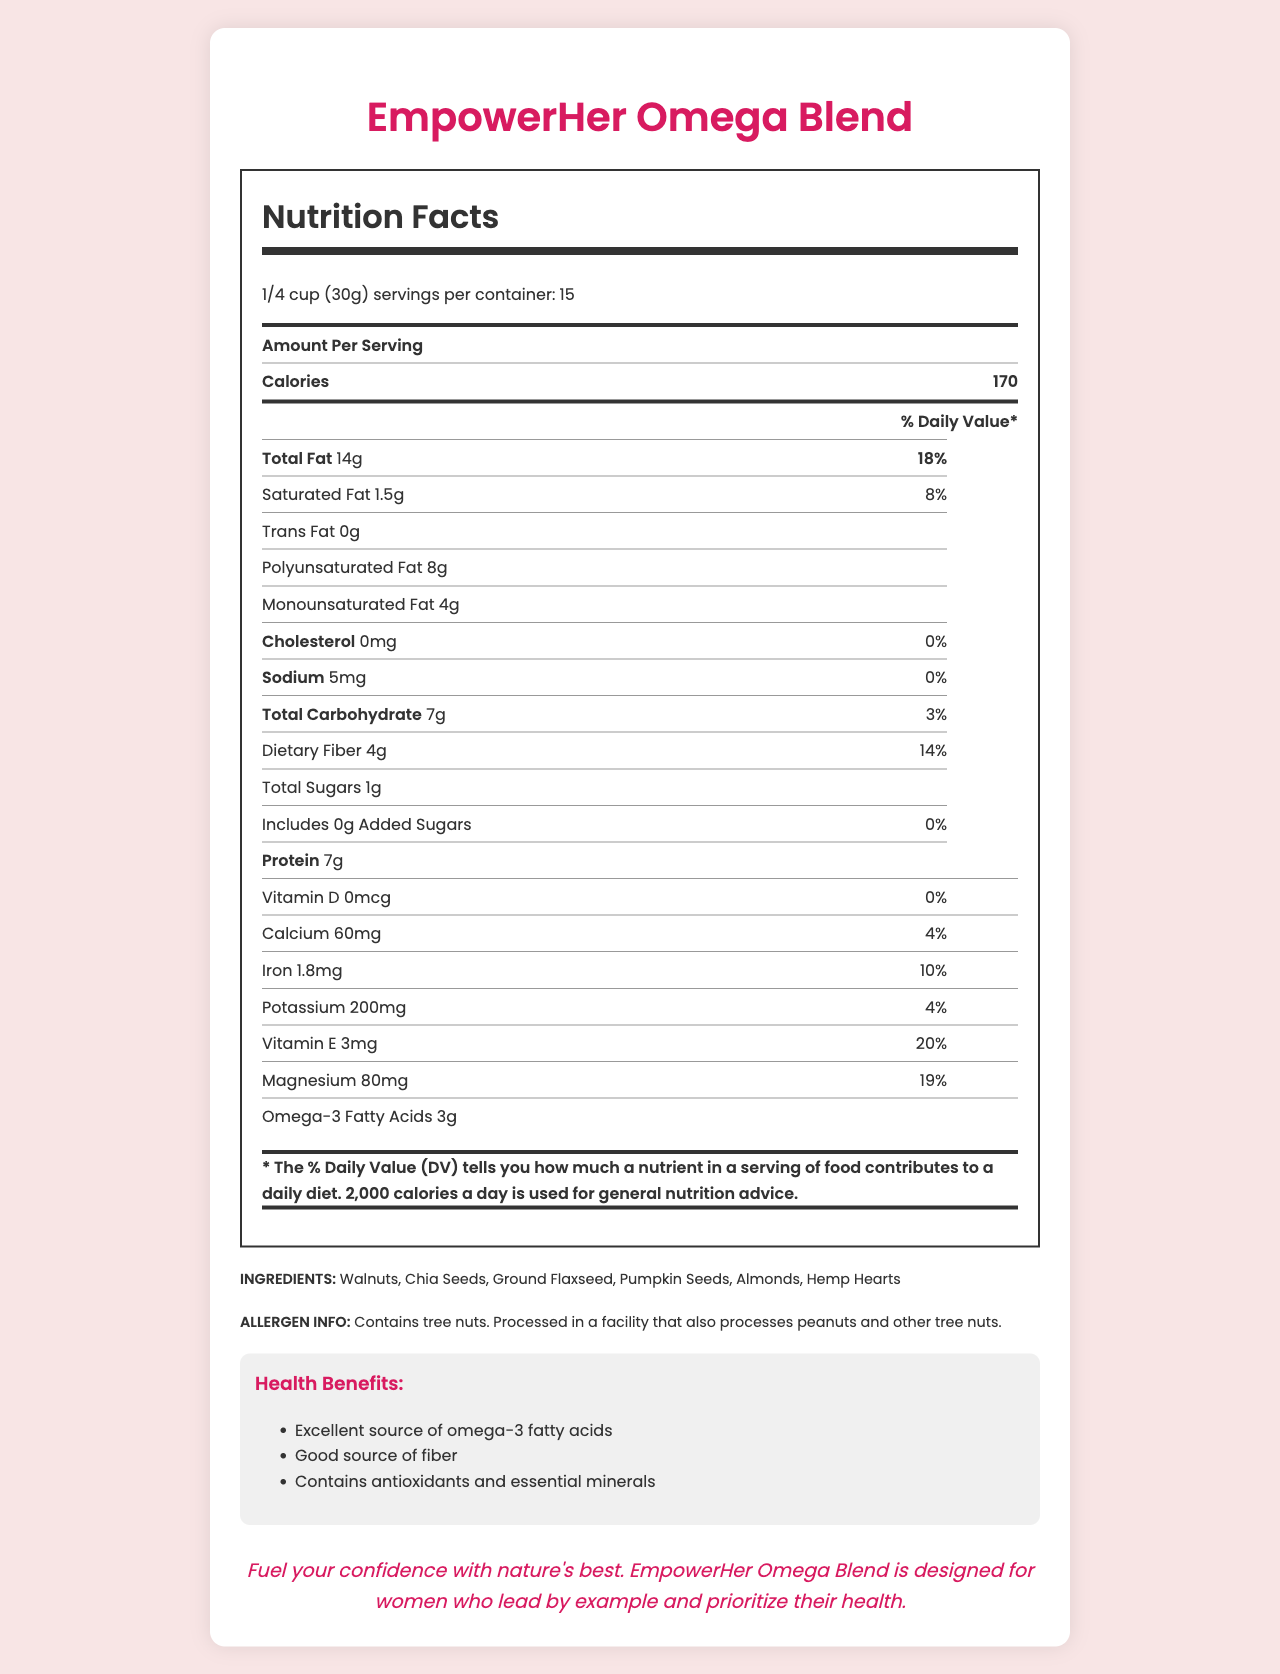what is the serving size of EmpowerHer Omega Blend? The serving size is explicitly mentioned at the top of the Nutrition Facts section.
Answer: 1/4 cup (30g) how many calories are in one serving? The document lists the number of calories per serving as 170 in the Amount Per Serving section.
Answer: 170 what is the total fat content per serving? The Total Fat content is listed as 14g directly under the Amount Per Serving section.
Answer: 14g what ingredients are included in the blend? The ingredients are listed in the INGREDIENTS section at the bottom of the document.
Answer: Walnuts, Chia Seeds, Ground Flaxseed, Pumpkin Seeds, Almonds, Hemp Hearts what percentage of the daily value of vitamin E does a serving provide? The daily value percentage for vitamin E is listed as 20% in the nutrition table.
Answer: 20% what is the amount of dietary fiber in a serving? A. 3g B. 4g C. 5g D. 7g The dietary fiber content is mentioned as 4g in the Total Carbohydrate section of the document.
Answer: B which of the following health benefits is NOT claimed for EmpowerHer Omega Blend? I. Contains antioxidants and essential minerals II. Excellent source of omega-3 fatty acids III. Supports heart health IV. Good source of fiber The listed health claims in the document are: Excellent source of omega-3 fatty acids, Good source of fiber, and Contains antioxidants and essential minerals. Supporting heart health is not mentioned.
Answer: III. Supports heart health does the product contain any added sugars? The nutritional information lists "Includes 0g Added Sugars" with a daily value of 0%.
Answer: No is the product processed in a facility that also processes peanuts? The allergen information clearly states that the product is processed in a facility that also processes peanuts.
Answer: Yes summarize the main idea of the document. The document includes a detailed Nutrition Facts label, a list of ingredients, allergen information, claimed health benefits, and an empowering message, all targeting women's health.
Answer: EmpowerHer Omega Blend provides nutrition facts, ingredient details, and health benefits targeted for women's health, highlighting its composition of omega-3 fatty acids, fiber, and essential minerals. what is the product's main source of protein? The document provides the total protein content per serving but does not specify which ingredient(s) are the main source of protein.
Answer: Cannot be determined 